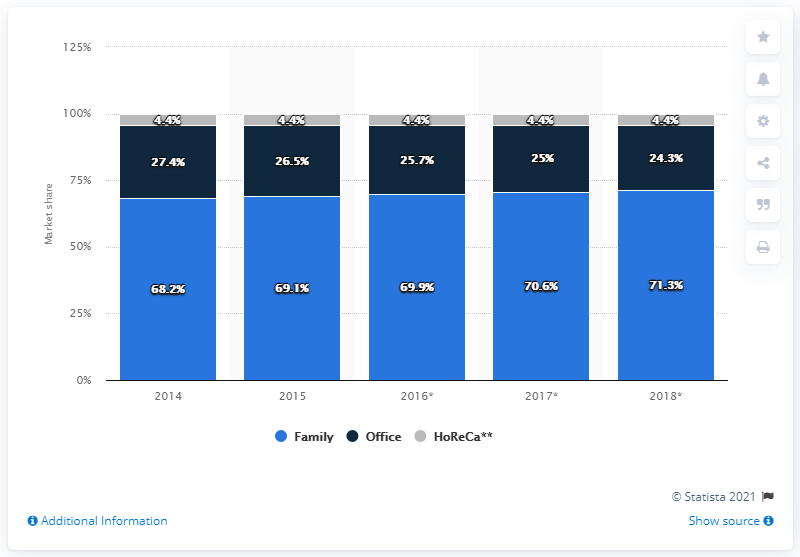Highlight a few significant elements in this photo. During the period of 2014 to 2018, the market share of coffee pods and capsules intended for families in Italy was 68.2%. According to data from 2014 to 2018, the market share of coffee pods and capsules intended for families in Italy was 71.3%. The market share of coffee pods and capsules for the HoReCa industry was 68.2%. 